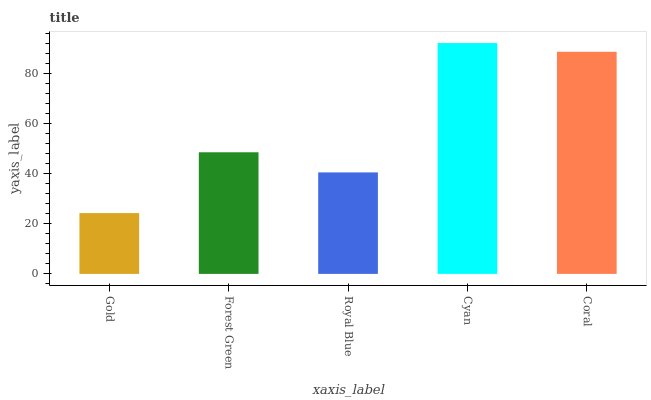Is Gold the minimum?
Answer yes or no. Yes. Is Cyan the maximum?
Answer yes or no. Yes. Is Forest Green the minimum?
Answer yes or no. No. Is Forest Green the maximum?
Answer yes or no. No. Is Forest Green greater than Gold?
Answer yes or no. Yes. Is Gold less than Forest Green?
Answer yes or no. Yes. Is Gold greater than Forest Green?
Answer yes or no. No. Is Forest Green less than Gold?
Answer yes or no. No. Is Forest Green the high median?
Answer yes or no. Yes. Is Forest Green the low median?
Answer yes or no. Yes. Is Gold the high median?
Answer yes or no. No. Is Gold the low median?
Answer yes or no. No. 